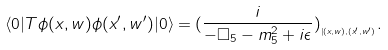<formula> <loc_0><loc_0><loc_500><loc_500>\langle 0 | T \phi ( x , w ) \phi ( x ^ { \prime } , w ^ { \prime } ) | 0 \rangle = ( \frac { i } { - \Box _ { 5 } - m _ { 5 } ^ { 2 } + i \epsilon } ) _ { _ { | { ( x , w ) , ( x ^ { \prime } , w ^ { \prime } ) } } } .</formula> 